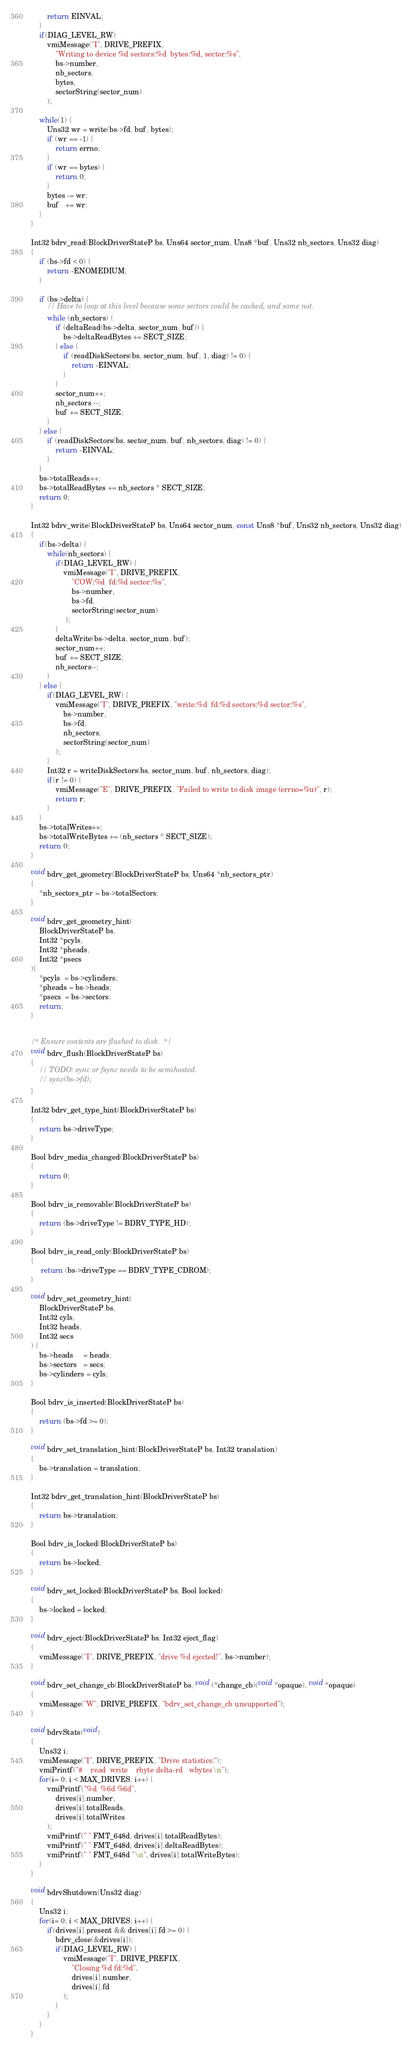<code> <loc_0><loc_0><loc_500><loc_500><_C_>        return EINVAL;
    }
    if(DIAG_LEVEL_RW)
        vmiMessage("I", DRIVE_PREFIX,
            "Writing to device %d sectors:%d  bytes:%d, sector:%s",
            bs->number,
            nb_sectors,
            bytes,
            sectorString(sector_num)
        );

    while(1) {
        Uns32 wr = write(bs->fd, buf, bytes);
        if (wr == -1) {
            return errno;
        }
        if (wr == bytes) {
            return 0;
        }
        bytes -= wr;
        buf   += wr;
    }
}

Int32 bdrv_read(BlockDriverStateP bs, Uns64 sector_num, Uns8 *buf, Uns32 nb_sectors, Uns32 diag)
{
    if (bs->fd < 0) {
        return -ENOMEDIUM;
    }

    if (bs->delta) {
        // Have to loop at this level because some sectors could be cached, and some not.
        while (nb_sectors) {
            if (deltaRead(bs->delta, sector_num, buf)) {
                bs->deltaReadBytes += SECT_SIZE;
            } else {
                if (readDiskSectors(bs, sector_num, buf, 1, diag) != 0) {
                    return -EINVAL;
                }
            }
            sector_num++;
            nb_sectors --;
            buf += SECT_SIZE;
        }
    } else {
        if (readDiskSectors(bs, sector_num, buf, nb_sectors, diag) != 0) {
            return -EINVAL;
        }
    }
    bs->totalReads++;
    bs->totalReadBytes += nb_sectors * SECT_SIZE;
    return 0;
}

Int32 bdrv_write(BlockDriverStateP bs, Uns64 sector_num, const Uns8 *buf, Uns32 nb_sectors, Uns32 diag)
{
    if(bs->delta) {
        while(nb_sectors) {
            if(DIAG_LEVEL_RW) {
                vmiMessage("I", DRIVE_PREFIX,
                    "COW:%d  fd:%d sector:%s",
                    bs->number,
                    bs->fd,
                    sectorString(sector_num)
                 );
            }
            deltaWrite(bs->delta, sector_num, buf);
            sector_num++;
            buf += SECT_SIZE;
            nb_sectors--;
        }
    } else {
        if(DIAG_LEVEL_RW) {
            vmiMessage("I", DRIVE_PREFIX, "write:%d  fd:%d sectors:%d sector:%s",
                bs->number,
                bs->fd,
                nb_sectors,
                sectorString(sector_num)
            );
        }
        Int32 r = writeDiskSectors(bs, sector_num, buf, nb_sectors, diag);
        if(r != 0) {
            vmiMessage("E", DRIVE_PREFIX, "Failed to write to disk image (errno=%u)", r);
            return r;
        }
    }
    bs->totalWrites++;
    bs->totalWriteBytes += (nb_sectors * SECT_SIZE);
    return 0;
}

void bdrv_get_geometry(BlockDriverStateP bs, Uns64 *nb_sectors_ptr)
{
    *nb_sectors_ptr = bs->totalSectors;
}

void bdrv_get_geometry_hint(
    BlockDriverStateP bs,
    Int32 *pcyls,
    Int32 *pheads,
    Int32 *psecs
){
    *pcyls  = bs->cylinders;
    *pheads = bs->heads;
    *psecs  = bs->sectors;
    return;
}


/* Ensure contents are flushed to disk.  */
void bdrv_flush(BlockDriverStateP bs)
{
    // TODO: sync or fsync needs to be semihosted.
    // sync(bs->fd);
}

Int32 bdrv_get_type_hint(BlockDriverStateP bs)
{
    return bs->driveType;
}

Bool bdrv_media_changed(BlockDriverStateP bs)
{
    return 0;
}

Bool bdrv_is_removable(BlockDriverStateP bs)
{
    return (bs->driveType != BDRV_TYPE_HD);
}

Bool bdrv_is_read_only(BlockDriverStateP bs)
{
     return (bs->driveType == BDRV_TYPE_CDROM);
}

void bdrv_set_geometry_hint(
    BlockDriverStateP bs,
    Int32 cyls,
    Int32 heads,
    Int32 secs
) {
    bs->heads     = heads;
    bs->sectors   = secs;
    bs->cylinders = cyls;
}

Bool bdrv_is_inserted(BlockDriverStateP bs)
{
    return (bs->fd >= 0);
}

void bdrv_set_translation_hint(BlockDriverStateP bs, Int32 translation)
{
    bs->translation = translation;
}

Int32 bdrv_get_translation_hint(BlockDriverStateP bs)
{
    return bs->translation;
}

Bool bdrv_is_locked(BlockDriverStateP bs)
{
    return bs->locked;
}

void bdrv_set_locked(BlockDriverStateP bs, Bool locked)
{
    bs->locked = locked;
}

void bdrv_eject(BlockDriverStateP bs, Int32 eject_flag)
{
    vmiMessage("I", DRIVE_PREFIX, "drive %d ejected!", bs->number);
}

void bdrv_set_change_cb(BlockDriverStateP bs, void (*change_cb)(void *opaque), void *opaque)
{
    vmiMessage("W", DRIVE_PREFIX, "bdrv_set_change_cb unsupported");
}

void bdrvStats(void)
{
    Uns32 i;
    vmiMessage("I", DRIVE_PREFIX, "Drive statistics:");
    vmiPrintf("#    read  write    rbyte delta-rd   wbytes\n");
    for(i= 0; i < MAX_DRIVES; i++) {
        vmiPrintf("%d  %6d %6d",
            drives[i].number,
            drives[i].totalReads,
            drives[i].totalWrites
        );
        vmiPrintf(" " FMT_648d, drives[i].totalReadBytes);
        vmiPrintf(" " FMT_648d, drives[i].deltaReadBytes);
        vmiPrintf(" " FMT_648d "\n", drives[i].totalWriteBytes);
    }
}

void bdrvShutdown(Uns32 diag)
{
    Uns32 i;
    for(i= 0; i < MAX_DRIVES; i++) {
        if(drives[i].present && drives[i].fd >= 0) {
            bdrv_close(&drives[i]);
            if(DIAG_LEVEL_RW) {
                vmiMessage("I", DRIVE_PREFIX,
                    "Closing %d fd:%d",
                    drives[i].number,
                    drives[i].fd
                );
            }
        }
    }
}
</code> 